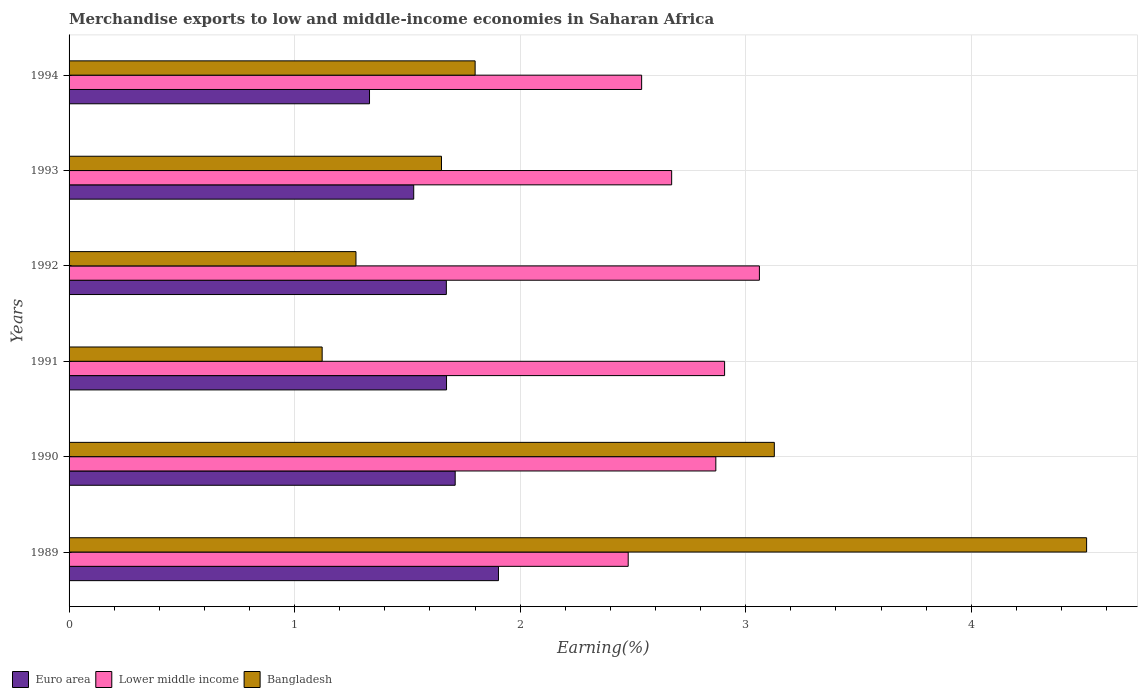How many different coloured bars are there?
Your answer should be very brief. 3. Are the number of bars on each tick of the Y-axis equal?
Provide a succinct answer. Yes. What is the label of the 2nd group of bars from the top?
Offer a terse response. 1993. What is the percentage of amount earned from merchandise exports in Lower middle income in 1990?
Keep it short and to the point. 2.87. Across all years, what is the maximum percentage of amount earned from merchandise exports in Euro area?
Provide a succinct answer. 1.9. Across all years, what is the minimum percentage of amount earned from merchandise exports in Lower middle income?
Offer a terse response. 2.48. In which year was the percentage of amount earned from merchandise exports in Bangladesh maximum?
Provide a short and direct response. 1989. What is the total percentage of amount earned from merchandise exports in Euro area in the graph?
Give a very brief answer. 9.82. What is the difference between the percentage of amount earned from merchandise exports in Bangladesh in 1991 and that in 1994?
Provide a short and direct response. -0.68. What is the difference between the percentage of amount earned from merchandise exports in Bangladesh in 1992 and the percentage of amount earned from merchandise exports in Lower middle income in 1993?
Make the answer very short. -1.4. What is the average percentage of amount earned from merchandise exports in Bangladesh per year?
Make the answer very short. 2.25. In the year 1993, what is the difference between the percentage of amount earned from merchandise exports in Lower middle income and percentage of amount earned from merchandise exports in Euro area?
Your answer should be compact. 1.14. In how many years, is the percentage of amount earned from merchandise exports in Bangladesh greater than 2.6 %?
Give a very brief answer. 2. What is the ratio of the percentage of amount earned from merchandise exports in Bangladesh in 1991 to that in 1993?
Your answer should be compact. 0.68. Is the percentage of amount earned from merchandise exports in Euro area in 1993 less than that in 1994?
Provide a succinct answer. No. What is the difference between the highest and the second highest percentage of amount earned from merchandise exports in Lower middle income?
Your answer should be compact. 0.15. What is the difference between the highest and the lowest percentage of amount earned from merchandise exports in Bangladesh?
Ensure brevity in your answer.  3.39. In how many years, is the percentage of amount earned from merchandise exports in Bangladesh greater than the average percentage of amount earned from merchandise exports in Bangladesh taken over all years?
Provide a succinct answer. 2. What does the 2nd bar from the top in 1993 represents?
Your answer should be very brief. Lower middle income. Is it the case that in every year, the sum of the percentage of amount earned from merchandise exports in Euro area and percentage of amount earned from merchandise exports in Bangladesh is greater than the percentage of amount earned from merchandise exports in Lower middle income?
Keep it short and to the point. No. How many bars are there?
Give a very brief answer. 18. Are all the bars in the graph horizontal?
Ensure brevity in your answer.  Yes. What is the difference between two consecutive major ticks on the X-axis?
Provide a succinct answer. 1. Does the graph contain grids?
Keep it short and to the point. Yes. How many legend labels are there?
Provide a short and direct response. 3. How are the legend labels stacked?
Ensure brevity in your answer.  Horizontal. What is the title of the graph?
Make the answer very short. Merchandise exports to low and middle-income economies in Saharan Africa. What is the label or title of the X-axis?
Ensure brevity in your answer.  Earning(%). What is the Earning(%) in Euro area in 1989?
Give a very brief answer. 1.9. What is the Earning(%) of Lower middle income in 1989?
Keep it short and to the point. 2.48. What is the Earning(%) of Bangladesh in 1989?
Your response must be concise. 4.51. What is the Earning(%) in Euro area in 1990?
Offer a terse response. 1.71. What is the Earning(%) in Lower middle income in 1990?
Your answer should be very brief. 2.87. What is the Earning(%) of Bangladesh in 1990?
Make the answer very short. 3.13. What is the Earning(%) of Euro area in 1991?
Your answer should be compact. 1.67. What is the Earning(%) in Lower middle income in 1991?
Make the answer very short. 2.91. What is the Earning(%) of Bangladesh in 1991?
Make the answer very short. 1.12. What is the Earning(%) in Euro area in 1992?
Your response must be concise. 1.67. What is the Earning(%) in Lower middle income in 1992?
Provide a short and direct response. 3.06. What is the Earning(%) of Bangladesh in 1992?
Provide a short and direct response. 1.27. What is the Earning(%) in Euro area in 1993?
Your answer should be very brief. 1.53. What is the Earning(%) of Lower middle income in 1993?
Your answer should be very brief. 2.67. What is the Earning(%) of Bangladesh in 1993?
Make the answer very short. 1.65. What is the Earning(%) in Euro area in 1994?
Your answer should be very brief. 1.33. What is the Earning(%) of Lower middle income in 1994?
Your response must be concise. 2.54. What is the Earning(%) in Bangladesh in 1994?
Offer a terse response. 1.8. Across all years, what is the maximum Earning(%) in Euro area?
Keep it short and to the point. 1.9. Across all years, what is the maximum Earning(%) of Lower middle income?
Keep it short and to the point. 3.06. Across all years, what is the maximum Earning(%) of Bangladesh?
Your answer should be very brief. 4.51. Across all years, what is the minimum Earning(%) of Euro area?
Your response must be concise. 1.33. Across all years, what is the minimum Earning(%) of Lower middle income?
Provide a short and direct response. 2.48. Across all years, what is the minimum Earning(%) in Bangladesh?
Make the answer very short. 1.12. What is the total Earning(%) in Euro area in the graph?
Make the answer very short. 9.82. What is the total Earning(%) in Lower middle income in the graph?
Your response must be concise. 16.52. What is the total Earning(%) in Bangladesh in the graph?
Make the answer very short. 13.48. What is the difference between the Earning(%) of Euro area in 1989 and that in 1990?
Offer a very short reply. 0.19. What is the difference between the Earning(%) of Lower middle income in 1989 and that in 1990?
Provide a short and direct response. -0.39. What is the difference between the Earning(%) of Bangladesh in 1989 and that in 1990?
Your answer should be compact. 1.38. What is the difference between the Earning(%) of Euro area in 1989 and that in 1991?
Ensure brevity in your answer.  0.23. What is the difference between the Earning(%) of Lower middle income in 1989 and that in 1991?
Keep it short and to the point. -0.43. What is the difference between the Earning(%) in Bangladesh in 1989 and that in 1991?
Provide a short and direct response. 3.39. What is the difference between the Earning(%) of Euro area in 1989 and that in 1992?
Offer a very short reply. 0.23. What is the difference between the Earning(%) in Lower middle income in 1989 and that in 1992?
Your answer should be compact. -0.58. What is the difference between the Earning(%) of Bangladesh in 1989 and that in 1992?
Provide a short and direct response. 3.24. What is the difference between the Earning(%) of Euro area in 1989 and that in 1993?
Offer a very short reply. 0.38. What is the difference between the Earning(%) in Lower middle income in 1989 and that in 1993?
Offer a very short reply. -0.19. What is the difference between the Earning(%) in Bangladesh in 1989 and that in 1993?
Make the answer very short. 2.86. What is the difference between the Earning(%) in Euro area in 1989 and that in 1994?
Keep it short and to the point. 0.57. What is the difference between the Earning(%) in Lower middle income in 1989 and that in 1994?
Keep it short and to the point. -0.06. What is the difference between the Earning(%) of Bangladesh in 1989 and that in 1994?
Make the answer very short. 2.71. What is the difference between the Earning(%) in Euro area in 1990 and that in 1991?
Offer a very short reply. 0.04. What is the difference between the Earning(%) of Lower middle income in 1990 and that in 1991?
Provide a succinct answer. -0.04. What is the difference between the Earning(%) in Bangladesh in 1990 and that in 1991?
Your answer should be compact. 2. What is the difference between the Earning(%) in Euro area in 1990 and that in 1992?
Make the answer very short. 0.04. What is the difference between the Earning(%) of Lower middle income in 1990 and that in 1992?
Your answer should be very brief. -0.19. What is the difference between the Earning(%) in Bangladesh in 1990 and that in 1992?
Offer a terse response. 1.85. What is the difference between the Earning(%) in Euro area in 1990 and that in 1993?
Offer a terse response. 0.18. What is the difference between the Earning(%) in Lower middle income in 1990 and that in 1993?
Provide a succinct answer. 0.2. What is the difference between the Earning(%) in Bangladesh in 1990 and that in 1993?
Your response must be concise. 1.48. What is the difference between the Earning(%) in Euro area in 1990 and that in 1994?
Offer a very short reply. 0.38. What is the difference between the Earning(%) in Lower middle income in 1990 and that in 1994?
Your response must be concise. 0.33. What is the difference between the Earning(%) of Bangladesh in 1990 and that in 1994?
Provide a succinct answer. 1.33. What is the difference between the Earning(%) in Euro area in 1991 and that in 1992?
Ensure brevity in your answer.  0. What is the difference between the Earning(%) of Lower middle income in 1991 and that in 1992?
Give a very brief answer. -0.15. What is the difference between the Earning(%) in Bangladesh in 1991 and that in 1992?
Offer a very short reply. -0.15. What is the difference between the Earning(%) in Euro area in 1991 and that in 1993?
Offer a terse response. 0.15. What is the difference between the Earning(%) of Lower middle income in 1991 and that in 1993?
Your response must be concise. 0.23. What is the difference between the Earning(%) of Bangladesh in 1991 and that in 1993?
Offer a very short reply. -0.53. What is the difference between the Earning(%) of Euro area in 1991 and that in 1994?
Your answer should be compact. 0.34. What is the difference between the Earning(%) of Lower middle income in 1991 and that in 1994?
Offer a very short reply. 0.37. What is the difference between the Earning(%) in Bangladesh in 1991 and that in 1994?
Your response must be concise. -0.68. What is the difference between the Earning(%) in Euro area in 1992 and that in 1993?
Make the answer very short. 0.14. What is the difference between the Earning(%) of Lower middle income in 1992 and that in 1993?
Your response must be concise. 0.39. What is the difference between the Earning(%) in Bangladesh in 1992 and that in 1993?
Ensure brevity in your answer.  -0.38. What is the difference between the Earning(%) of Euro area in 1992 and that in 1994?
Make the answer very short. 0.34. What is the difference between the Earning(%) of Lower middle income in 1992 and that in 1994?
Provide a succinct answer. 0.52. What is the difference between the Earning(%) of Bangladesh in 1992 and that in 1994?
Give a very brief answer. -0.53. What is the difference between the Earning(%) in Euro area in 1993 and that in 1994?
Offer a terse response. 0.2. What is the difference between the Earning(%) in Lower middle income in 1993 and that in 1994?
Ensure brevity in your answer.  0.13. What is the difference between the Earning(%) in Bangladesh in 1993 and that in 1994?
Ensure brevity in your answer.  -0.15. What is the difference between the Earning(%) in Euro area in 1989 and the Earning(%) in Lower middle income in 1990?
Keep it short and to the point. -0.96. What is the difference between the Earning(%) in Euro area in 1989 and the Earning(%) in Bangladesh in 1990?
Your answer should be compact. -1.22. What is the difference between the Earning(%) in Lower middle income in 1989 and the Earning(%) in Bangladesh in 1990?
Give a very brief answer. -0.65. What is the difference between the Earning(%) in Euro area in 1989 and the Earning(%) in Lower middle income in 1991?
Your answer should be very brief. -1. What is the difference between the Earning(%) in Euro area in 1989 and the Earning(%) in Bangladesh in 1991?
Your response must be concise. 0.78. What is the difference between the Earning(%) in Lower middle income in 1989 and the Earning(%) in Bangladesh in 1991?
Make the answer very short. 1.36. What is the difference between the Earning(%) of Euro area in 1989 and the Earning(%) of Lower middle income in 1992?
Keep it short and to the point. -1.16. What is the difference between the Earning(%) in Euro area in 1989 and the Earning(%) in Bangladesh in 1992?
Your response must be concise. 0.63. What is the difference between the Earning(%) of Lower middle income in 1989 and the Earning(%) of Bangladesh in 1992?
Your answer should be very brief. 1.21. What is the difference between the Earning(%) of Euro area in 1989 and the Earning(%) of Lower middle income in 1993?
Your answer should be very brief. -0.77. What is the difference between the Earning(%) in Euro area in 1989 and the Earning(%) in Bangladesh in 1993?
Keep it short and to the point. 0.25. What is the difference between the Earning(%) in Lower middle income in 1989 and the Earning(%) in Bangladesh in 1993?
Give a very brief answer. 0.83. What is the difference between the Earning(%) of Euro area in 1989 and the Earning(%) of Lower middle income in 1994?
Provide a short and direct response. -0.63. What is the difference between the Earning(%) in Euro area in 1989 and the Earning(%) in Bangladesh in 1994?
Provide a succinct answer. 0.1. What is the difference between the Earning(%) of Lower middle income in 1989 and the Earning(%) of Bangladesh in 1994?
Your response must be concise. 0.68. What is the difference between the Earning(%) in Euro area in 1990 and the Earning(%) in Lower middle income in 1991?
Ensure brevity in your answer.  -1.19. What is the difference between the Earning(%) in Euro area in 1990 and the Earning(%) in Bangladesh in 1991?
Ensure brevity in your answer.  0.59. What is the difference between the Earning(%) in Lower middle income in 1990 and the Earning(%) in Bangladesh in 1991?
Offer a very short reply. 1.75. What is the difference between the Earning(%) in Euro area in 1990 and the Earning(%) in Lower middle income in 1992?
Your response must be concise. -1.35. What is the difference between the Earning(%) of Euro area in 1990 and the Earning(%) of Bangladesh in 1992?
Ensure brevity in your answer.  0.44. What is the difference between the Earning(%) in Lower middle income in 1990 and the Earning(%) in Bangladesh in 1992?
Your answer should be very brief. 1.6. What is the difference between the Earning(%) of Euro area in 1990 and the Earning(%) of Lower middle income in 1993?
Your response must be concise. -0.96. What is the difference between the Earning(%) of Euro area in 1990 and the Earning(%) of Bangladesh in 1993?
Give a very brief answer. 0.06. What is the difference between the Earning(%) in Lower middle income in 1990 and the Earning(%) in Bangladesh in 1993?
Keep it short and to the point. 1.22. What is the difference between the Earning(%) of Euro area in 1990 and the Earning(%) of Lower middle income in 1994?
Your answer should be very brief. -0.83. What is the difference between the Earning(%) in Euro area in 1990 and the Earning(%) in Bangladesh in 1994?
Provide a short and direct response. -0.09. What is the difference between the Earning(%) in Lower middle income in 1990 and the Earning(%) in Bangladesh in 1994?
Offer a terse response. 1.07. What is the difference between the Earning(%) of Euro area in 1991 and the Earning(%) of Lower middle income in 1992?
Offer a very short reply. -1.39. What is the difference between the Earning(%) in Euro area in 1991 and the Earning(%) in Bangladesh in 1992?
Keep it short and to the point. 0.4. What is the difference between the Earning(%) in Lower middle income in 1991 and the Earning(%) in Bangladesh in 1992?
Ensure brevity in your answer.  1.63. What is the difference between the Earning(%) of Euro area in 1991 and the Earning(%) of Lower middle income in 1993?
Keep it short and to the point. -1. What is the difference between the Earning(%) in Euro area in 1991 and the Earning(%) in Bangladesh in 1993?
Offer a very short reply. 0.02. What is the difference between the Earning(%) in Lower middle income in 1991 and the Earning(%) in Bangladesh in 1993?
Provide a short and direct response. 1.26. What is the difference between the Earning(%) of Euro area in 1991 and the Earning(%) of Lower middle income in 1994?
Give a very brief answer. -0.86. What is the difference between the Earning(%) of Euro area in 1991 and the Earning(%) of Bangladesh in 1994?
Ensure brevity in your answer.  -0.13. What is the difference between the Earning(%) of Lower middle income in 1991 and the Earning(%) of Bangladesh in 1994?
Ensure brevity in your answer.  1.11. What is the difference between the Earning(%) in Euro area in 1992 and the Earning(%) in Lower middle income in 1993?
Provide a succinct answer. -1. What is the difference between the Earning(%) of Euro area in 1992 and the Earning(%) of Bangladesh in 1993?
Keep it short and to the point. 0.02. What is the difference between the Earning(%) in Lower middle income in 1992 and the Earning(%) in Bangladesh in 1993?
Provide a succinct answer. 1.41. What is the difference between the Earning(%) of Euro area in 1992 and the Earning(%) of Lower middle income in 1994?
Your answer should be compact. -0.87. What is the difference between the Earning(%) of Euro area in 1992 and the Earning(%) of Bangladesh in 1994?
Make the answer very short. -0.13. What is the difference between the Earning(%) of Lower middle income in 1992 and the Earning(%) of Bangladesh in 1994?
Give a very brief answer. 1.26. What is the difference between the Earning(%) of Euro area in 1993 and the Earning(%) of Lower middle income in 1994?
Make the answer very short. -1.01. What is the difference between the Earning(%) of Euro area in 1993 and the Earning(%) of Bangladesh in 1994?
Your response must be concise. -0.27. What is the difference between the Earning(%) of Lower middle income in 1993 and the Earning(%) of Bangladesh in 1994?
Provide a succinct answer. 0.87. What is the average Earning(%) of Euro area per year?
Provide a short and direct response. 1.64. What is the average Earning(%) in Lower middle income per year?
Make the answer very short. 2.75. What is the average Earning(%) of Bangladesh per year?
Offer a very short reply. 2.25. In the year 1989, what is the difference between the Earning(%) in Euro area and Earning(%) in Lower middle income?
Offer a very short reply. -0.58. In the year 1989, what is the difference between the Earning(%) in Euro area and Earning(%) in Bangladesh?
Your response must be concise. -2.61. In the year 1989, what is the difference between the Earning(%) of Lower middle income and Earning(%) of Bangladesh?
Offer a very short reply. -2.03. In the year 1990, what is the difference between the Earning(%) of Euro area and Earning(%) of Lower middle income?
Give a very brief answer. -1.16. In the year 1990, what is the difference between the Earning(%) of Euro area and Earning(%) of Bangladesh?
Your answer should be compact. -1.42. In the year 1990, what is the difference between the Earning(%) in Lower middle income and Earning(%) in Bangladesh?
Offer a very short reply. -0.26. In the year 1991, what is the difference between the Earning(%) of Euro area and Earning(%) of Lower middle income?
Make the answer very short. -1.23. In the year 1991, what is the difference between the Earning(%) in Euro area and Earning(%) in Bangladesh?
Give a very brief answer. 0.55. In the year 1991, what is the difference between the Earning(%) of Lower middle income and Earning(%) of Bangladesh?
Your response must be concise. 1.78. In the year 1992, what is the difference between the Earning(%) of Euro area and Earning(%) of Lower middle income?
Keep it short and to the point. -1.39. In the year 1992, what is the difference between the Earning(%) in Euro area and Earning(%) in Bangladesh?
Your answer should be compact. 0.4. In the year 1992, what is the difference between the Earning(%) in Lower middle income and Earning(%) in Bangladesh?
Offer a very short reply. 1.79. In the year 1993, what is the difference between the Earning(%) of Euro area and Earning(%) of Lower middle income?
Ensure brevity in your answer.  -1.14. In the year 1993, what is the difference between the Earning(%) in Euro area and Earning(%) in Bangladesh?
Your answer should be compact. -0.12. In the year 1993, what is the difference between the Earning(%) of Lower middle income and Earning(%) of Bangladesh?
Your answer should be very brief. 1.02. In the year 1994, what is the difference between the Earning(%) of Euro area and Earning(%) of Lower middle income?
Offer a terse response. -1.21. In the year 1994, what is the difference between the Earning(%) of Euro area and Earning(%) of Bangladesh?
Make the answer very short. -0.47. In the year 1994, what is the difference between the Earning(%) of Lower middle income and Earning(%) of Bangladesh?
Your response must be concise. 0.74. What is the ratio of the Earning(%) in Euro area in 1989 to that in 1990?
Your answer should be compact. 1.11. What is the ratio of the Earning(%) of Lower middle income in 1989 to that in 1990?
Your answer should be compact. 0.86. What is the ratio of the Earning(%) of Bangladesh in 1989 to that in 1990?
Give a very brief answer. 1.44. What is the ratio of the Earning(%) in Euro area in 1989 to that in 1991?
Make the answer very short. 1.14. What is the ratio of the Earning(%) of Lower middle income in 1989 to that in 1991?
Your response must be concise. 0.85. What is the ratio of the Earning(%) of Bangladesh in 1989 to that in 1991?
Your answer should be very brief. 4.02. What is the ratio of the Earning(%) of Euro area in 1989 to that in 1992?
Keep it short and to the point. 1.14. What is the ratio of the Earning(%) of Lower middle income in 1989 to that in 1992?
Keep it short and to the point. 0.81. What is the ratio of the Earning(%) in Bangladesh in 1989 to that in 1992?
Your answer should be compact. 3.55. What is the ratio of the Earning(%) in Euro area in 1989 to that in 1993?
Make the answer very short. 1.25. What is the ratio of the Earning(%) of Lower middle income in 1989 to that in 1993?
Keep it short and to the point. 0.93. What is the ratio of the Earning(%) of Bangladesh in 1989 to that in 1993?
Ensure brevity in your answer.  2.73. What is the ratio of the Earning(%) in Euro area in 1989 to that in 1994?
Provide a short and direct response. 1.43. What is the ratio of the Earning(%) of Lower middle income in 1989 to that in 1994?
Provide a short and direct response. 0.98. What is the ratio of the Earning(%) of Bangladesh in 1989 to that in 1994?
Provide a succinct answer. 2.51. What is the ratio of the Earning(%) of Euro area in 1990 to that in 1991?
Your answer should be compact. 1.02. What is the ratio of the Earning(%) of Lower middle income in 1990 to that in 1991?
Your response must be concise. 0.99. What is the ratio of the Earning(%) of Bangladesh in 1990 to that in 1991?
Make the answer very short. 2.79. What is the ratio of the Earning(%) in Euro area in 1990 to that in 1992?
Make the answer very short. 1.02. What is the ratio of the Earning(%) of Lower middle income in 1990 to that in 1992?
Give a very brief answer. 0.94. What is the ratio of the Earning(%) in Bangladesh in 1990 to that in 1992?
Offer a very short reply. 2.46. What is the ratio of the Earning(%) of Euro area in 1990 to that in 1993?
Make the answer very short. 1.12. What is the ratio of the Earning(%) in Lower middle income in 1990 to that in 1993?
Your answer should be very brief. 1.07. What is the ratio of the Earning(%) in Bangladesh in 1990 to that in 1993?
Offer a terse response. 1.89. What is the ratio of the Earning(%) of Euro area in 1990 to that in 1994?
Your answer should be compact. 1.29. What is the ratio of the Earning(%) in Lower middle income in 1990 to that in 1994?
Provide a succinct answer. 1.13. What is the ratio of the Earning(%) in Bangladesh in 1990 to that in 1994?
Your answer should be compact. 1.74. What is the ratio of the Earning(%) in Lower middle income in 1991 to that in 1992?
Make the answer very short. 0.95. What is the ratio of the Earning(%) of Bangladesh in 1991 to that in 1992?
Give a very brief answer. 0.88. What is the ratio of the Earning(%) of Euro area in 1991 to that in 1993?
Make the answer very short. 1.1. What is the ratio of the Earning(%) of Lower middle income in 1991 to that in 1993?
Make the answer very short. 1.09. What is the ratio of the Earning(%) in Bangladesh in 1991 to that in 1993?
Make the answer very short. 0.68. What is the ratio of the Earning(%) of Euro area in 1991 to that in 1994?
Provide a succinct answer. 1.26. What is the ratio of the Earning(%) of Lower middle income in 1991 to that in 1994?
Ensure brevity in your answer.  1.14. What is the ratio of the Earning(%) of Bangladesh in 1991 to that in 1994?
Ensure brevity in your answer.  0.62. What is the ratio of the Earning(%) of Euro area in 1992 to that in 1993?
Ensure brevity in your answer.  1.09. What is the ratio of the Earning(%) of Lower middle income in 1992 to that in 1993?
Offer a very short reply. 1.15. What is the ratio of the Earning(%) in Bangladesh in 1992 to that in 1993?
Give a very brief answer. 0.77. What is the ratio of the Earning(%) in Euro area in 1992 to that in 1994?
Offer a very short reply. 1.26. What is the ratio of the Earning(%) of Lower middle income in 1992 to that in 1994?
Ensure brevity in your answer.  1.21. What is the ratio of the Earning(%) of Bangladesh in 1992 to that in 1994?
Give a very brief answer. 0.71. What is the ratio of the Earning(%) of Euro area in 1993 to that in 1994?
Keep it short and to the point. 1.15. What is the ratio of the Earning(%) in Lower middle income in 1993 to that in 1994?
Make the answer very short. 1.05. What is the ratio of the Earning(%) of Bangladesh in 1993 to that in 1994?
Your answer should be very brief. 0.92. What is the difference between the highest and the second highest Earning(%) of Euro area?
Offer a terse response. 0.19. What is the difference between the highest and the second highest Earning(%) in Lower middle income?
Your answer should be very brief. 0.15. What is the difference between the highest and the second highest Earning(%) of Bangladesh?
Provide a succinct answer. 1.38. What is the difference between the highest and the lowest Earning(%) in Euro area?
Make the answer very short. 0.57. What is the difference between the highest and the lowest Earning(%) in Lower middle income?
Your answer should be very brief. 0.58. What is the difference between the highest and the lowest Earning(%) of Bangladesh?
Your response must be concise. 3.39. 